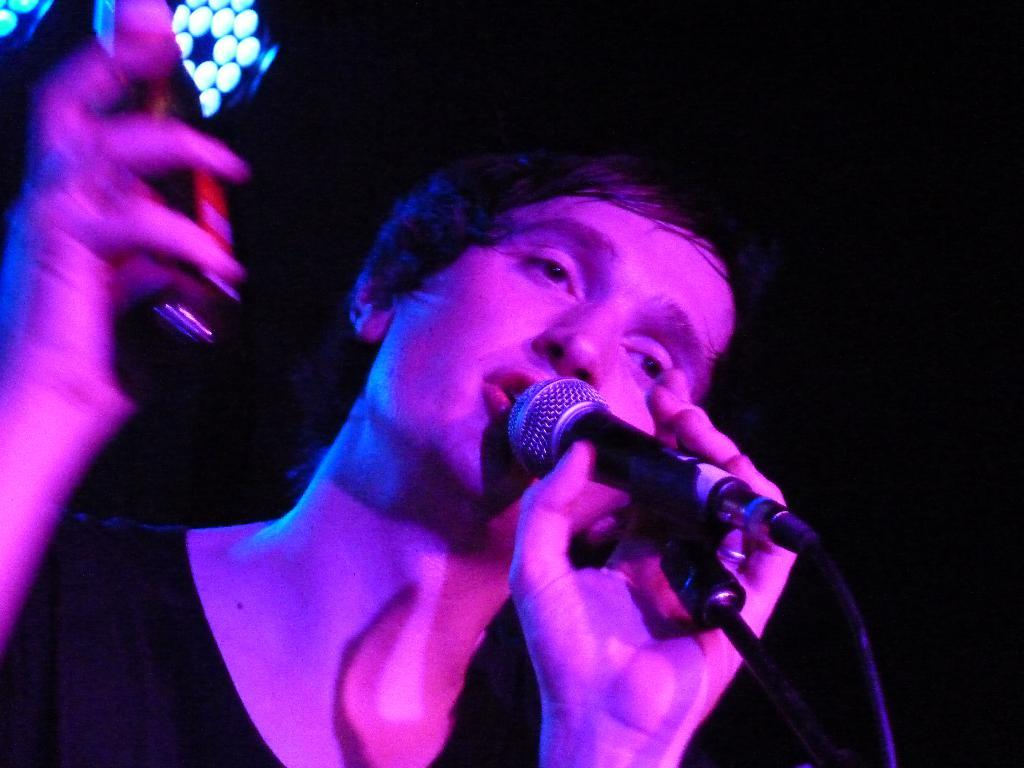Who is the main subject in the image? There is a man in the image. What is the man holding in his hand? The man is holding a mic with his hand. What is the man doing with the mic? The man is speaking into the mic. What can be seen in the background of the image? The background of the image is dark. What else is visible in the image besides the man and the mic? There are lights visible in the image. What is the distance between the man and the cord in the image? There is no cord present in the image, so it is not possible to determine the distance between the man and a cord. 